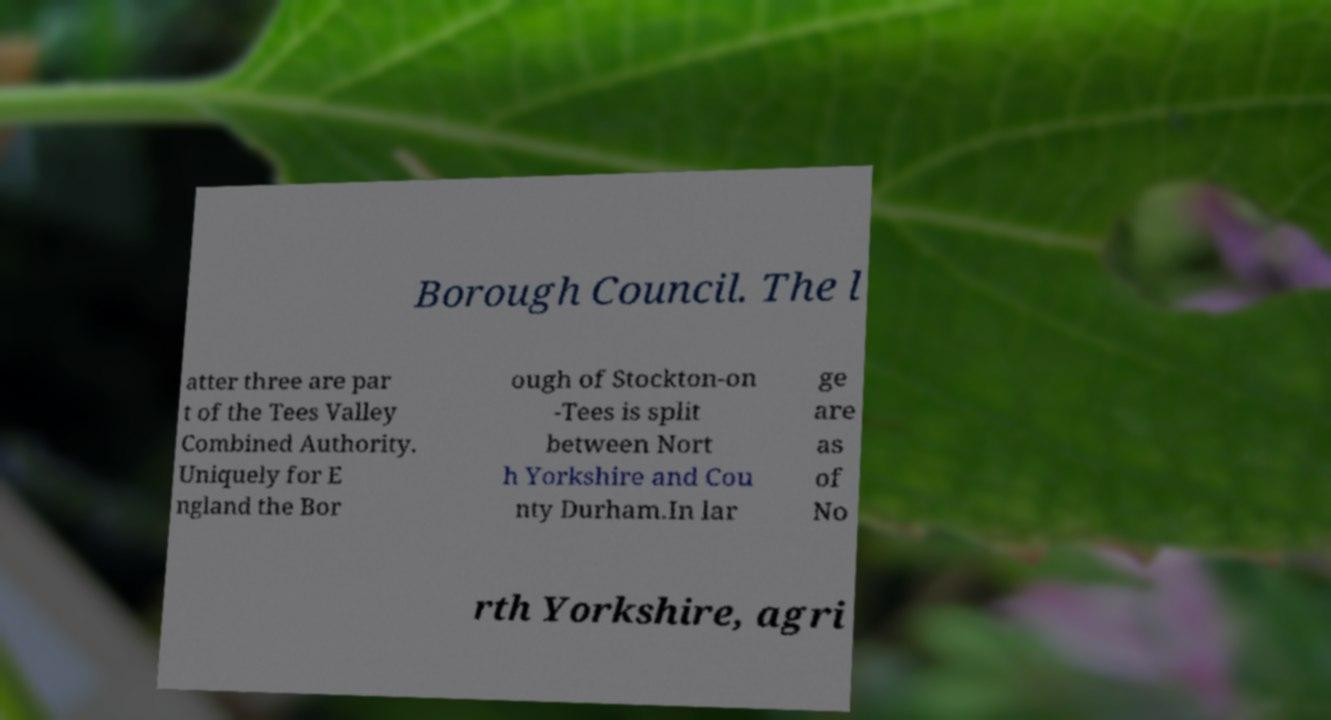There's text embedded in this image that I need extracted. Can you transcribe it verbatim? Borough Council. The l atter three are par t of the Tees Valley Combined Authority. Uniquely for E ngland the Bor ough of Stockton-on -Tees is split between Nort h Yorkshire and Cou nty Durham.In lar ge are as of No rth Yorkshire, agri 